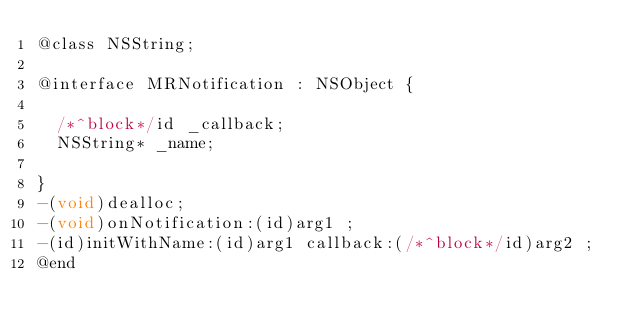Convert code to text. <code><loc_0><loc_0><loc_500><loc_500><_C_>@class NSString;

@interface MRNotification : NSObject {

	/*^block*/id _callback;
	NSString* _name;

}
-(void)dealloc;
-(void)onNotification:(id)arg1 ;
-(id)initWithName:(id)arg1 callback:(/*^block*/id)arg2 ;
@end

</code> 